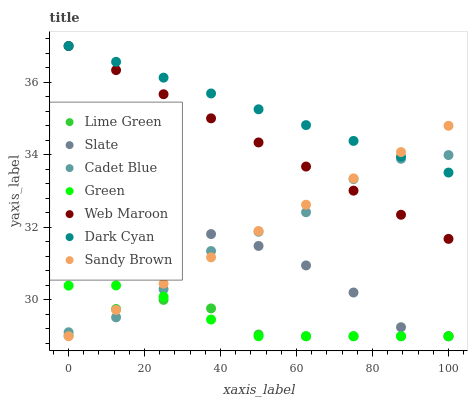Does Lime Green have the minimum area under the curve?
Answer yes or no. Yes. Does Dark Cyan have the maximum area under the curve?
Answer yes or no. Yes. Does Sandy Brown have the minimum area under the curve?
Answer yes or no. No. Does Sandy Brown have the maximum area under the curve?
Answer yes or no. No. Is Web Maroon the smoothest?
Answer yes or no. Yes. Is Cadet Blue the roughest?
Answer yes or no. Yes. Is Sandy Brown the smoothest?
Answer yes or no. No. Is Sandy Brown the roughest?
Answer yes or no. No. Does Sandy Brown have the lowest value?
Answer yes or no. Yes. Does Web Maroon have the lowest value?
Answer yes or no. No. Does Dark Cyan have the highest value?
Answer yes or no. Yes. Does Sandy Brown have the highest value?
Answer yes or no. No. Is Slate less than Web Maroon?
Answer yes or no. Yes. Is Dark Cyan greater than Slate?
Answer yes or no. Yes. Does Sandy Brown intersect Slate?
Answer yes or no. Yes. Is Sandy Brown less than Slate?
Answer yes or no. No. Is Sandy Brown greater than Slate?
Answer yes or no. No. Does Slate intersect Web Maroon?
Answer yes or no. No. 